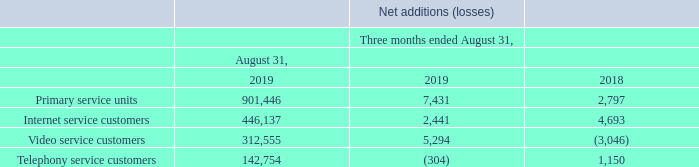CUSTOMER STATISTICS
INTERNET Fiscal 2019 fourth-quarter Internet service customers net additions stood at 2,441 compared to 4,693 for the same period of the prior year as a result of: • additional connects related to the Florida expansion initiatives and in the MetroCast footprint; • our customers' ongoing interest in high speed offerings; and • growth in both the residential and business sectors.
VIDEO Fiscal 2019 fourth-quarter video service customers net additions stood at 5,294 compared to net losses of 3,046 for the same period of the prior year mainly from: • the activation of bulk properties in Florida during the fourth quarter of fiscal 2019; and • our customers' ongoing interest in TiVo's digital advanced video services; partly offset by • competitive offers in the industry; and • a changing video consumption environment.
TELEPHONY Fiscal 2019 fourth-quarter telephony service customers net losses stood at 304 compared to net additions of 1,150 for the same period of the prior year mainly as a result of a decline in the residential sector, partly offset by growth in the business sector. TELEPHONY Fiscal 2019 fourth-quarter telephony service customers net losses stood at 304 compared to net additions of 1,150 for the same period of the prior year mainly as a result of a decline in the residential sector, partly offset by growth in the business sector.
What were the total number of internet service customers net additions in fourth quarter 2019?  2,441. What were the total number of video service customers net additions in fourth quarter 2019?  5,294. What were the total number of telephony service customers net losses in fourth quarter 2019?  304. What was the increase / (decrease) in Net additions (losses) for the Primary service units from 31 Aug 2018 to 31 Aug 2019? 7,431 - 2,797
Answer: 4634. What was the average Net additions (losses) for internet service customers? (2,441 + 4,693) / 2
Answer: 3567. What was the average Net additions (losses) for video service customers? (5,294 + (- 3,046)) / 2
Answer: 1124. 